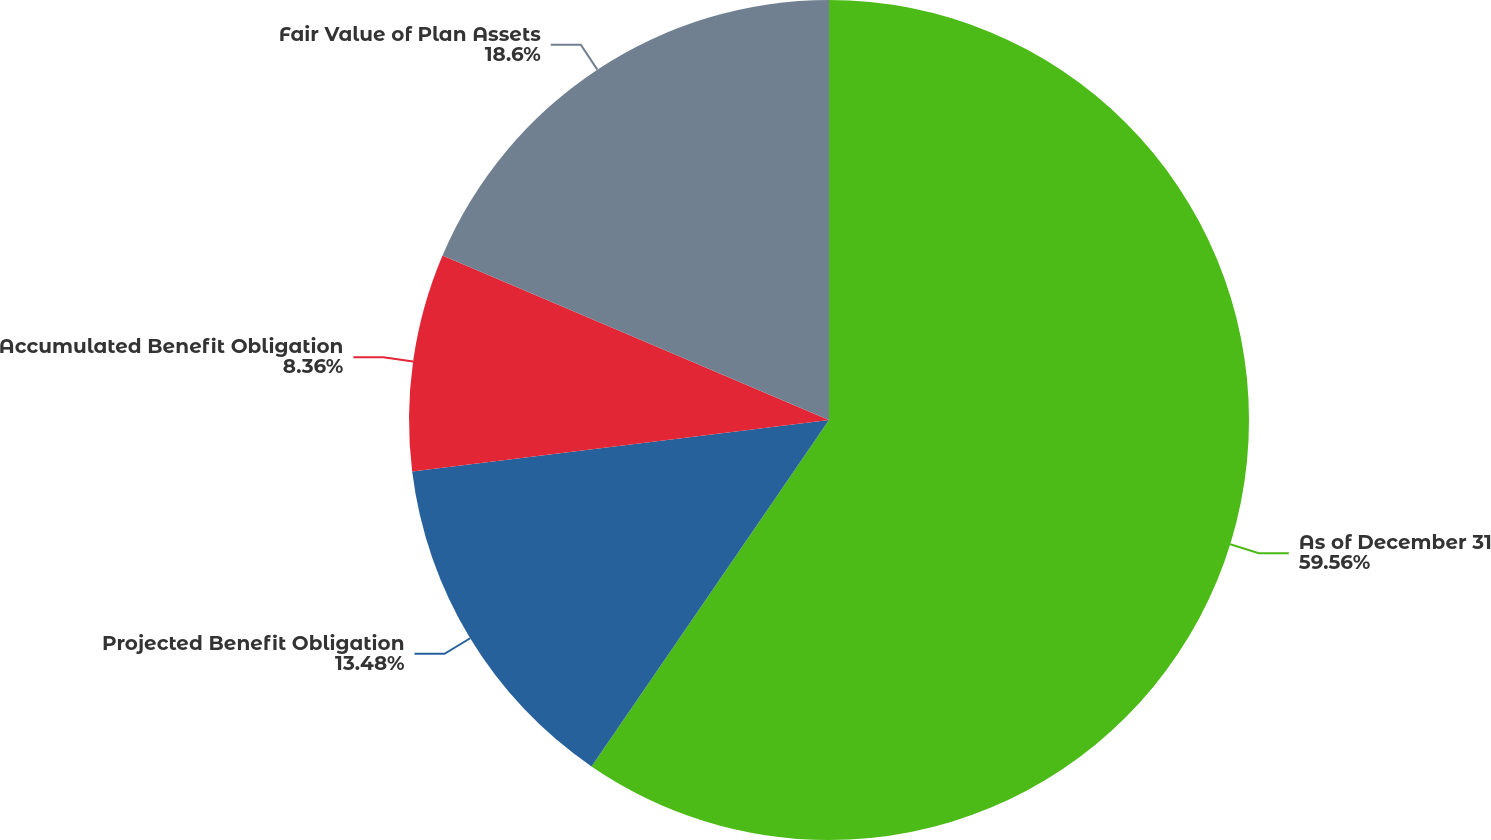Convert chart to OTSL. <chart><loc_0><loc_0><loc_500><loc_500><pie_chart><fcel>As of December 31<fcel>Projected Benefit Obligation<fcel>Accumulated Benefit Obligation<fcel>Fair Value of Plan Assets<nl><fcel>59.57%<fcel>13.48%<fcel>8.36%<fcel>18.6%<nl></chart> 